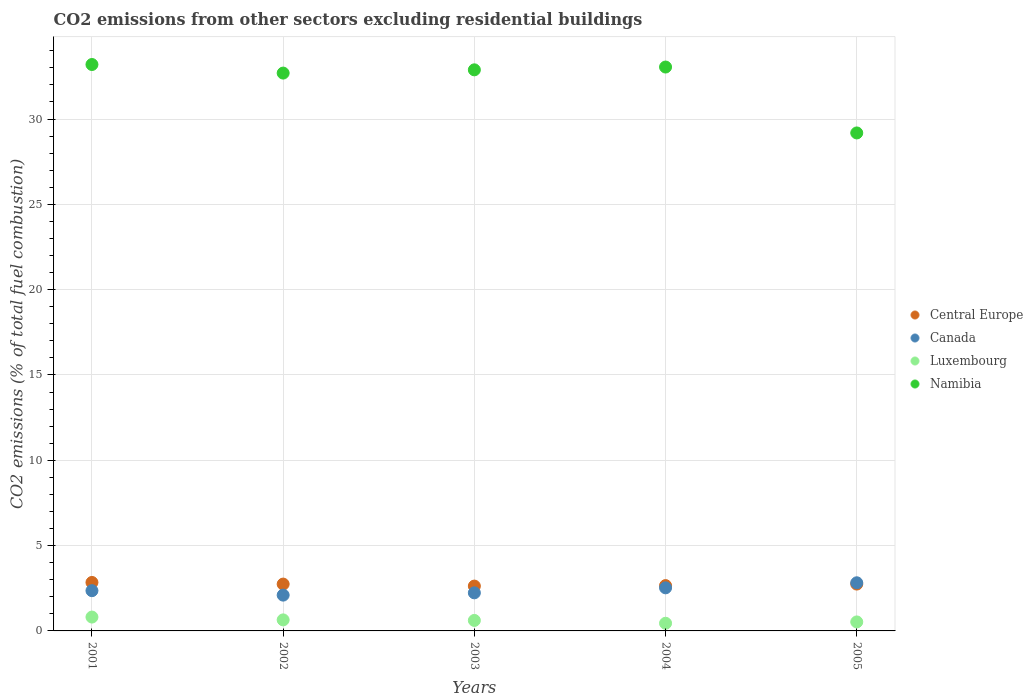What is the total CO2 emitted in Namibia in 2004?
Your response must be concise. 33.05. Across all years, what is the maximum total CO2 emitted in Central Europe?
Make the answer very short. 2.84. Across all years, what is the minimum total CO2 emitted in Luxembourg?
Provide a succinct answer. 0.45. What is the total total CO2 emitted in Namibia in the graph?
Your answer should be very brief. 161. What is the difference between the total CO2 emitted in Canada in 2003 and that in 2004?
Offer a terse response. -0.29. What is the difference between the total CO2 emitted in Luxembourg in 2003 and the total CO2 emitted in Canada in 2005?
Offer a very short reply. -2.21. What is the average total CO2 emitted in Luxembourg per year?
Your answer should be very brief. 0.61. In the year 2002, what is the difference between the total CO2 emitted in Namibia and total CO2 emitted in Luxembourg?
Keep it short and to the point. 32.05. In how many years, is the total CO2 emitted in Namibia greater than 9?
Your answer should be very brief. 5. What is the ratio of the total CO2 emitted in Namibia in 2002 to that in 2005?
Your response must be concise. 1.12. Is the total CO2 emitted in Namibia in 2002 less than that in 2003?
Provide a short and direct response. Yes. What is the difference between the highest and the second highest total CO2 emitted in Canada?
Your answer should be very brief. 0.3. What is the difference between the highest and the lowest total CO2 emitted in Central Europe?
Provide a succinct answer. 0.21. Is the sum of the total CO2 emitted in Canada in 2003 and 2004 greater than the maximum total CO2 emitted in Luxembourg across all years?
Keep it short and to the point. Yes. Is the total CO2 emitted in Canada strictly greater than the total CO2 emitted in Central Europe over the years?
Keep it short and to the point. No. How many dotlines are there?
Your response must be concise. 4. How many years are there in the graph?
Keep it short and to the point. 5. What is the difference between two consecutive major ticks on the Y-axis?
Provide a short and direct response. 5. Are the values on the major ticks of Y-axis written in scientific E-notation?
Keep it short and to the point. No. Does the graph contain grids?
Your answer should be compact. Yes. How many legend labels are there?
Give a very brief answer. 4. How are the legend labels stacked?
Make the answer very short. Vertical. What is the title of the graph?
Provide a succinct answer. CO2 emissions from other sectors excluding residential buildings. Does "Bolivia" appear as one of the legend labels in the graph?
Offer a very short reply. No. What is the label or title of the Y-axis?
Give a very brief answer. CO2 emissions (% of total fuel combustion). What is the CO2 emissions (% of total fuel combustion) in Central Europe in 2001?
Ensure brevity in your answer.  2.84. What is the CO2 emissions (% of total fuel combustion) in Canada in 2001?
Provide a short and direct response. 2.36. What is the CO2 emissions (% of total fuel combustion) of Luxembourg in 2001?
Make the answer very short. 0.81. What is the CO2 emissions (% of total fuel combustion) in Namibia in 2001?
Provide a succinct answer. 33.2. What is the CO2 emissions (% of total fuel combustion) of Central Europe in 2002?
Offer a terse response. 2.74. What is the CO2 emissions (% of total fuel combustion) of Canada in 2002?
Your answer should be very brief. 2.1. What is the CO2 emissions (% of total fuel combustion) in Luxembourg in 2002?
Ensure brevity in your answer.  0.65. What is the CO2 emissions (% of total fuel combustion) of Namibia in 2002?
Give a very brief answer. 32.69. What is the CO2 emissions (% of total fuel combustion) of Central Europe in 2003?
Your response must be concise. 2.63. What is the CO2 emissions (% of total fuel combustion) in Canada in 2003?
Your answer should be compact. 2.23. What is the CO2 emissions (% of total fuel combustion) of Luxembourg in 2003?
Your response must be concise. 0.61. What is the CO2 emissions (% of total fuel combustion) in Namibia in 2003?
Offer a very short reply. 32.88. What is the CO2 emissions (% of total fuel combustion) in Central Europe in 2004?
Ensure brevity in your answer.  2.66. What is the CO2 emissions (% of total fuel combustion) of Canada in 2004?
Make the answer very short. 2.53. What is the CO2 emissions (% of total fuel combustion) in Luxembourg in 2004?
Offer a very short reply. 0.45. What is the CO2 emissions (% of total fuel combustion) of Namibia in 2004?
Your answer should be very brief. 33.05. What is the CO2 emissions (% of total fuel combustion) in Central Europe in 2005?
Your answer should be very brief. 2.75. What is the CO2 emissions (% of total fuel combustion) of Canada in 2005?
Provide a short and direct response. 2.82. What is the CO2 emissions (% of total fuel combustion) of Luxembourg in 2005?
Ensure brevity in your answer.  0.53. What is the CO2 emissions (% of total fuel combustion) in Namibia in 2005?
Your response must be concise. 29.18. Across all years, what is the maximum CO2 emissions (% of total fuel combustion) in Central Europe?
Give a very brief answer. 2.84. Across all years, what is the maximum CO2 emissions (% of total fuel combustion) in Canada?
Offer a very short reply. 2.82. Across all years, what is the maximum CO2 emissions (% of total fuel combustion) of Luxembourg?
Your answer should be very brief. 0.81. Across all years, what is the maximum CO2 emissions (% of total fuel combustion) of Namibia?
Give a very brief answer. 33.2. Across all years, what is the minimum CO2 emissions (% of total fuel combustion) of Central Europe?
Your answer should be very brief. 2.63. Across all years, what is the minimum CO2 emissions (% of total fuel combustion) of Canada?
Provide a short and direct response. 2.1. Across all years, what is the minimum CO2 emissions (% of total fuel combustion) of Luxembourg?
Make the answer very short. 0.45. Across all years, what is the minimum CO2 emissions (% of total fuel combustion) of Namibia?
Provide a succinct answer. 29.18. What is the total CO2 emissions (% of total fuel combustion) in Central Europe in the graph?
Your response must be concise. 13.62. What is the total CO2 emissions (% of total fuel combustion) of Canada in the graph?
Your answer should be very brief. 12.03. What is the total CO2 emissions (% of total fuel combustion) of Luxembourg in the graph?
Give a very brief answer. 3.05. What is the total CO2 emissions (% of total fuel combustion) in Namibia in the graph?
Keep it short and to the point. 161. What is the difference between the CO2 emissions (% of total fuel combustion) of Central Europe in 2001 and that in 2002?
Offer a terse response. 0.1. What is the difference between the CO2 emissions (% of total fuel combustion) in Canada in 2001 and that in 2002?
Give a very brief answer. 0.26. What is the difference between the CO2 emissions (% of total fuel combustion) in Luxembourg in 2001 and that in 2002?
Your response must be concise. 0.17. What is the difference between the CO2 emissions (% of total fuel combustion) in Namibia in 2001 and that in 2002?
Provide a succinct answer. 0.5. What is the difference between the CO2 emissions (% of total fuel combustion) in Central Europe in 2001 and that in 2003?
Make the answer very short. 0.21. What is the difference between the CO2 emissions (% of total fuel combustion) of Canada in 2001 and that in 2003?
Ensure brevity in your answer.  0.13. What is the difference between the CO2 emissions (% of total fuel combustion) of Luxembourg in 2001 and that in 2003?
Ensure brevity in your answer.  0.2. What is the difference between the CO2 emissions (% of total fuel combustion) in Namibia in 2001 and that in 2003?
Offer a very short reply. 0.31. What is the difference between the CO2 emissions (% of total fuel combustion) of Central Europe in 2001 and that in 2004?
Give a very brief answer. 0.18. What is the difference between the CO2 emissions (% of total fuel combustion) of Canada in 2001 and that in 2004?
Your response must be concise. -0.17. What is the difference between the CO2 emissions (% of total fuel combustion) in Luxembourg in 2001 and that in 2004?
Your response must be concise. 0.36. What is the difference between the CO2 emissions (% of total fuel combustion) in Namibia in 2001 and that in 2004?
Make the answer very short. 0.15. What is the difference between the CO2 emissions (% of total fuel combustion) in Central Europe in 2001 and that in 2005?
Ensure brevity in your answer.  0.09. What is the difference between the CO2 emissions (% of total fuel combustion) in Canada in 2001 and that in 2005?
Ensure brevity in your answer.  -0.46. What is the difference between the CO2 emissions (% of total fuel combustion) of Luxembourg in 2001 and that in 2005?
Provide a short and direct response. 0.28. What is the difference between the CO2 emissions (% of total fuel combustion) in Namibia in 2001 and that in 2005?
Your response must be concise. 4.01. What is the difference between the CO2 emissions (% of total fuel combustion) of Central Europe in 2002 and that in 2003?
Give a very brief answer. 0.12. What is the difference between the CO2 emissions (% of total fuel combustion) in Canada in 2002 and that in 2003?
Give a very brief answer. -0.13. What is the difference between the CO2 emissions (% of total fuel combustion) of Luxembourg in 2002 and that in 2003?
Ensure brevity in your answer.  0.03. What is the difference between the CO2 emissions (% of total fuel combustion) of Namibia in 2002 and that in 2003?
Make the answer very short. -0.19. What is the difference between the CO2 emissions (% of total fuel combustion) of Central Europe in 2002 and that in 2004?
Your response must be concise. 0.09. What is the difference between the CO2 emissions (% of total fuel combustion) of Canada in 2002 and that in 2004?
Your answer should be compact. -0.43. What is the difference between the CO2 emissions (% of total fuel combustion) of Luxembourg in 2002 and that in 2004?
Make the answer very short. 0.2. What is the difference between the CO2 emissions (% of total fuel combustion) in Namibia in 2002 and that in 2004?
Provide a short and direct response. -0.35. What is the difference between the CO2 emissions (% of total fuel combustion) of Central Europe in 2002 and that in 2005?
Give a very brief answer. -0. What is the difference between the CO2 emissions (% of total fuel combustion) in Canada in 2002 and that in 2005?
Keep it short and to the point. -0.72. What is the difference between the CO2 emissions (% of total fuel combustion) of Luxembourg in 2002 and that in 2005?
Your answer should be compact. 0.12. What is the difference between the CO2 emissions (% of total fuel combustion) in Namibia in 2002 and that in 2005?
Offer a very short reply. 3.51. What is the difference between the CO2 emissions (% of total fuel combustion) in Central Europe in 2003 and that in 2004?
Ensure brevity in your answer.  -0.03. What is the difference between the CO2 emissions (% of total fuel combustion) of Canada in 2003 and that in 2004?
Give a very brief answer. -0.29. What is the difference between the CO2 emissions (% of total fuel combustion) in Luxembourg in 2003 and that in 2004?
Your response must be concise. 0.17. What is the difference between the CO2 emissions (% of total fuel combustion) of Namibia in 2003 and that in 2004?
Your answer should be very brief. -0.16. What is the difference between the CO2 emissions (% of total fuel combustion) in Central Europe in 2003 and that in 2005?
Your answer should be very brief. -0.12. What is the difference between the CO2 emissions (% of total fuel combustion) in Canada in 2003 and that in 2005?
Offer a terse response. -0.59. What is the difference between the CO2 emissions (% of total fuel combustion) in Luxembourg in 2003 and that in 2005?
Offer a terse response. 0.09. What is the difference between the CO2 emissions (% of total fuel combustion) in Namibia in 2003 and that in 2005?
Your response must be concise. 3.7. What is the difference between the CO2 emissions (% of total fuel combustion) in Central Europe in 2004 and that in 2005?
Your answer should be compact. -0.09. What is the difference between the CO2 emissions (% of total fuel combustion) of Canada in 2004 and that in 2005?
Provide a succinct answer. -0.3. What is the difference between the CO2 emissions (% of total fuel combustion) of Luxembourg in 2004 and that in 2005?
Make the answer very short. -0.08. What is the difference between the CO2 emissions (% of total fuel combustion) of Namibia in 2004 and that in 2005?
Your response must be concise. 3.86. What is the difference between the CO2 emissions (% of total fuel combustion) in Central Europe in 2001 and the CO2 emissions (% of total fuel combustion) in Canada in 2002?
Your answer should be compact. 0.74. What is the difference between the CO2 emissions (% of total fuel combustion) in Central Europe in 2001 and the CO2 emissions (% of total fuel combustion) in Luxembourg in 2002?
Your answer should be very brief. 2.19. What is the difference between the CO2 emissions (% of total fuel combustion) of Central Europe in 2001 and the CO2 emissions (% of total fuel combustion) of Namibia in 2002?
Give a very brief answer. -29.85. What is the difference between the CO2 emissions (% of total fuel combustion) in Canada in 2001 and the CO2 emissions (% of total fuel combustion) in Luxembourg in 2002?
Offer a terse response. 1.71. What is the difference between the CO2 emissions (% of total fuel combustion) of Canada in 2001 and the CO2 emissions (% of total fuel combustion) of Namibia in 2002?
Your response must be concise. -30.33. What is the difference between the CO2 emissions (% of total fuel combustion) in Luxembourg in 2001 and the CO2 emissions (% of total fuel combustion) in Namibia in 2002?
Make the answer very short. -31.88. What is the difference between the CO2 emissions (% of total fuel combustion) in Central Europe in 2001 and the CO2 emissions (% of total fuel combustion) in Canada in 2003?
Give a very brief answer. 0.61. What is the difference between the CO2 emissions (% of total fuel combustion) of Central Europe in 2001 and the CO2 emissions (% of total fuel combustion) of Luxembourg in 2003?
Your answer should be very brief. 2.23. What is the difference between the CO2 emissions (% of total fuel combustion) in Central Europe in 2001 and the CO2 emissions (% of total fuel combustion) in Namibia in 2003?
Your answer should be compact. -30.04. What is the difference between the CO2 emissions (% of total fuel combustion) in Canada in 2001 and the CO2 emissions (% of total fuel combustion) in Luxembourg in 2003?
Keep it short and to the point. 1.74. What is the difference between the CO2 emissions (% of total fuel combustion) in Canada in 2001 and the CO2 emissions (% of total fuel combustion) in Namibia in 2003?
Offer a terse response. -30.52. What is the difference between the CO2 emissions (% of total fuel combustion) in Luxembourg in 2001 and the CO2 emissions (% of total fuel combustion) in Namibia in 2003?
Provide a succinct answer. -32.07. What is the difference between the CO2 emissions (% of total fuel combustion) of Central Europe in 2001 and the CO2 emissions (% of total fuel combustion) of Canada in 2004?
Offer a terse response. 0.32. What is the difference between the CO2 emissions (% of total fuel combustion) of Central Europe in 2001 and the CO2 emissions (% of total fuel combustion) of Luxembourg in 2004?
Provide a succinct answer. 2.39. What is the difference between the CO2 emissions (% of total fuel combustion) in Central Europe in 2001 and the CO2 emissions (% of total fuel combustion) in Namibia in 2004?
Your answer should be compact. -30.21. What is the difference between the CO2 emissions (% of total fuel combustion) of Canada in 2001 and the CO2 emissions (% of total fuel combustion) of Luxembourg in 2004?
Provide a short and direct response. 1.91. What is the difference between the CO2 emissions (% of total fuel combustion) of Canada in 2001 and the CO2 emissions (% of total fuel combustion) of Namibia in 2004?
Offer a terse response. -30.69. What is the difference between the CO2 emissions (% of total fuel combustion) of Luxembourg in 2001 and the CO2 emissions (% of total fuel combustion) of Namibia in 2004?
Offer a terse response. -32.24. What is the difference between the CO2 emissions (% of total fuel combustion) in Central Europe in 2001 and the CO2 emissions (% of total fuel combustion) in Canada in 2005?
Ensure brevity in your answer.  0.02. What is the difference between the CO2 emissions (% of total fuel combustion) in Central Europe in 2001 and the CO2 emissions (% of total fuel combustion) in Luxembourg in 2005?
Provide a succinct answer. 2.31. What is the difference between the CO2 emissions (% of total fuel combustion) of Central Europe in 2001 and the CO2 emissions (% of total fuel combustion) of Namibia in 2005?
Provide a succinct answer. -26.34. What is the difference between the CO2 emissions (% of total fuel combustion) in Canada in 2001 and the CO2 emissions (% of total fuel combustion) in Luxembourg in 2005?
Make the answer very short. 1.83. What is the difference between the CO2 emissions (% of total fuel combustion) of Canada in 2001 and the CO2 emissions (% of total fuel combustion) of Namibia in 2005?
Offer a terse response. -26.83. What is the difference between the CO2 emissions (% of total fuel combustion) of Luxembourg in 2001 and the CO2 emissions (% of total fuel combustion) of Namibia in 2005?
Ensure brevity in your answer.  -28.37. What is the difference between the CO2 emissions (% of total fuel combustion) of Central Europe in 2002 and the CO2 emissions (% of total fuel combustion) of Canada in 2003?
Make the answer very short. 0.51. What is the difference between the CO2 emissions (% of total fuel combustion) of Central Europe in 2002 and the CO2 emissions (% of total fuel combustion) of Luxembourg in 2003?
Your answer should be very brief. 2.13. What is the difference between the CO2 emissions (% of total fuel combustion) in Central Europe in 2002 and the CO2 emissions (% of total fuel combustion) in Namibia in 2003?
Your answer should be compact. -30.14. What is the difference between the CO2 emissions (% of total fuel combustion) of Canada in 2002 and the CO2 emissions (% of total fuel combustion) of Luxembourg in 2003?
Provide a short and direct response. 1.48. What is the difference between the CO2 emissions (% of total fuel combustion) in Canada in 2002 and the CO2 emissions (% of total fuel combustion) in Namibia in 2003?
Ensure brevity in your answer.  -30.78. What is the difference between the CO2 emissions (% of total fuel combustion) of Luxembourg in 2002 and the CO2 emissions (% of total fuel combustion) of Namibia in 2003?
Your response must be concise. -32.24. What is the difference between the CO2 emissions (% of total fuel combustion) of Central Europe in 2002 and the CO2 emissions (% of total fuel combustion) of Canada in 2004?
Ensure brevity in your answer.  0.22. What is the difference between the CO2 emissions (% of total fuel combustion) of Central Europe in 2002 and the CO2 emissions (% of total fuel combustion) of Luxembourg in 2004?
Provide a succinct answer. 2.3. What is the difference between the CO2 emissions (% of total fuel combustion) of Central Europe in 2002 and the CO2 emissions (% of total fuel combustion) of Namibia in 2004?
Your response must be concise. -30.3. What is the difference between the CO2 emissions (% of total fuel combustion) of Canada in 2002 and the CO2 emissions (% of total fuel combustion) of Luxembourg in 2004?
Your answer should be very brief. 1.65. What is the difference between the CO2 emissions (% of total fuel combustion) of Canada in 2002 and the CO2 emissions (% of total fuel combustion) of Namibia in 2004?
Give a very brief answer. -30.95. What is the difference between the CO2 emissions (% of total fuel combustion) of Luxembourg in 2002 and the CO2 emissions (% of total fuel combustion) of Namibia in 2004?
Keep it short and to the point. -32.4. What is the difference between the CO2 emissions (% of total fuel combustion) of Central Europe in 2002 and the CO2 emissions (% of total fuel combustion) of Canada in 2005?
Keep it short and to the point. -0.08. What is the difference between the CO2 emissions (% of total fuel combustion) of Central Europe in 2002 and the CO2 emissions (% of total fuel combustion) of Luxembourg in 2005?
Provide a short and direct response. 2.22. What is the difference between the CO2 emissions (% of total fuel combustion) of Central Europe in 2002 and the CO2 emissions (% of total fuel combustion) of Namibia in 2005?
Offer a terse response. -26.44. What is the difference between the CO2 emissions (% of total fuel combustion) in Canada in 2002 and the CO2 emissions (% of total fuel combustion) in Luxembourg in 2005?
Make the answer very short. 1.57. What is the difference between the CO2 emissions (% of total fuel combustion) in Canada in 2002 and the CO2 emissions (% of total fuel combustion) in Namibia in 2005?
Make the answer very short. -27.09. What is the difference between the CO2 emissions (% of total fuel combustion) of Luxembourg in 2002 and the CO2 emissions (% of total fuel combustion) of Namibia in 2005?
Ensure brevity in your answer.  -28.54. What is the difference between the CO2 emissions (% of total fuel combustion) of Central Europe in 2003 and the CO2 emissions (% of total fuel combustion) of Canada in 2004?
Your answer should be very brief. 0.1. What is the difference between the CO2 emissions (% of total fuel combustion) in Central Europe in 2003 and the CO2 emissions (% of total fuel combustion) in Luxembourg in 2004?
Ensure brevity in your answer.  2.18. What is the difference between the CO2 emissions (% of total fuel combustion) of Central Europe in 2003 and the CO2 emissions (% of total fuel combustion) of Namibia in 2004?
Give a very brief answer. -30.42. What is the difference between the CO2 emissions (% of total fuel combustion) of Canada in 2003 and the CO2 emissions (% of total fuel combustion) of Luxembourg in 2004?
Your answer should be very brief. 1.78. What is the difference between the CO2 emissions (% of total fuel combustion) in Canada in 2003 and the CO2 emissions (% of total fuel combustion) in Namibia in 2004?
Your answer should be very brief. -30.82. What is the difference between the CO2 emissions (% of total fuel combustion) of Luxembourg in 2003 and the CO2 emissions (% of total fuel combustion) of Namibia in 2004?
Keep it short and to the point. -32.43. What is the difference between the CO2 emissions (% of total fuel combustion) of Central Europe in 2003 and the CO2 emissions (% of total fuel combustion) of Canada in 2005?
Your answer should be compact. -0.19. What is the difference between the CO2 emissions (% of total fuel combustion) of Central Europe in 2003 and the CO2 emissions (% of total fuel combustion) of Luxembourg in 2005?
Your answer should be very brief. 2.1. What is the difference between the CO2 emissions (% of total fuel combustion) of Central Europe in 2003 and the CO2 emissions (% of total fuel combustion) of Namibia in 2005?
Ensure brevity in your answer.  -26.56. What is the difference between the CO2 emissions (% of total fuel combustion) of Canada in 2003 and the CO2 emissions (% of total fuel combustion) of Luxembourg in 2005?
Give a very brief answer. 1.7. What is the difference between the CO2 emissions (% of total fuel combustion) in Canada in 2003 and the CO2 emissions (% of total fuel combustion) in Namibia in 2005?
Make the answer very short. -26.95. What is the difference between the CO2 emissions (% of total fuel combustion) in Luxembourg in 2003 and the CO2 emissions (% of total fuel combustion) in Namibia in 2005?
Provide a succinct answer. -28.57. What is the difference between the CO2 emissions (% of total fuel combustion) of Central Europe in 2004 and the CO2 emissions (% of total fuel combustion) of Canada in 2005?
Offer a terse response. -0.16. What is the difference between the CO2 emissions (% of total fuel combustion) of Central Europe in 2004 and the CO2 emissions (% of total fuel combustion) of Luxembourg in 2005?
Ensure brevity in your answer.  2.13. What is the difference between the CO2 emissions (% of total fuel combustion) in Central Europe in 2004 and the CO2 emissions (% of total fuel combustion) in Namibia in 2005?
Offer a terse response. -26.53. What is the difference between the CO2 emissions (% of total fuel combustion) in Canada in 2004 and the CO2 emissions (% of total fuel combustion) in Luxembourg in 2005?
Offer a terse response. 2. What is the difference between the CO2 emissions (% of total fuel combustion) in Canada in 2004 and the CO2 emissions (% of total fuel combustion) in Namibia in 2005?
Your answer should be very brief. -26.66. What is the difference between the CO2 emissions (% of total fuel combustion) of Luxembourg in 2004 and the CO2 emissions (% of total fuel combustion) of Namibia in 2005?
Give a very brief answer. -28.74. What is the average CO2 emissions (% of total fuel combustion) of Central Europe per year?
Your response must be concise. 2.72. What is the average CO2 emissions (% of total fuel combustion) in Canada per year?
Give a very brief answer. 2.41. What is the average CO2 emissions (% of total fuel combustion) of Luxembourg per year?
Provide a succinct answer. 0.61. What is the average CO2 emissions (% of total fuel combustion) of Namibia per year?
Keep it short and to the point. 32.2. In the year 2001, what is the difference between the CO2 emissions (% of total fuel combustion) in Central Europe and CO2 emissions (% of total fuel combustion) in Canada?
Provide a short and direct response. 0.48. In the year 2001, what is the difference between the CO2 emissions (% of total fuel combustion) of Central Europe and CO2 emissions (% of total fuel combustion) of Luxembourg?
Provide a succinct answer. 2.03. In the year 2001, what is the difference between the CO2 emissions (% of total fuel combustion) of Central Europe and CO2 emissions (% of total fuel combustion) of Namibia?
Your response must be concise. -30.35. In the year 2001, what is the difference between the CO2 emissions (% of total fuel combustion) of Canada and CO2 emissions (% of total fuel combustion) of Luxembourg?
Keep it short and to the point. 1.55. In the year 2001, what is the difference between the CO2 emissions (% of total fuel combustion) in Canada and CO2 emissions (% of total fuel combustion) in Namibia?
Provide a short and direct response. -30.84. In the year 2001, what is the difference between the CO2 emissions (% of total fuel combustion) of Luxembourg and CO2 emissions (% of total fuel combustion) of Namibia?
Make the answer very short. -32.38. In the year 2002, what is the difference between the CO2 emissions (% of total fuel combustion) in Central Europe and CO2 emissions (% of total fuel combustion) in Canada?
Provide a short and direct response. 0.65. In the year 2002, what is the difference between the CO2 emissions (% of total fuel combustion) in Central Europe and CO2 emissions (% of total fuel combustion) in Luxembourg?
Make the answer very short. 2.1. In the year 2002, what is the difference between the CO2 emissions (% of total fuel combustion) in Central Europe and CO2 emissions (% of total fuel combustion) in Namibia?
Your response must be concise. -29.95. In the year 2002, what is the difference between the CO2 emissions (% of total fuel combustion) of Canada and CO2 emissions (% of total fuel combustion) of Luxembourg?
Your answer should be compact. 1.45. In the year 2002, what is the difference between the CO2 emissions (% of total fuel combustion) of Canada and CO2 emissions (% of total fuel combustion) of Namibia?
Your response must be concise. -30.59. In the year 2002, what is the difference between the CO2 emissions (% of total fuel combustion) of Luxembourg and CO2 emissions (% of total fuel combustion) of Namibia?
Your answer should be very brief. -32.05. In the year 2003, what is the difference between the CO2 emissions (% of total fuel combustion) of Central Europe and CO2 emissions (% of total fuel combustion) of Canada?
Your response must be concise. 0.4. In the year 2003, what is the difference between the CO2 emissions (% of total fuel combustion) of Central Europe and CO2 emissions (% of total fuel combustion) of Luxembourg?
Offer a terse response. 2.01. In the year 2003, what is the difference between the CO2 emissions (% of total fuel combustion) in Central Europe and CO2 emissions (% of total fuel combustion) in Namibia?
Ensure brevity in your answer.  -30.25. In the year 2003, what is the difference between the CO2 emissions (% of total fuel combustion) in Canada and CO2 emissions (% of total fuel combustion) in Luxembourg?
Ensure brevity in your answer.  1.62. In the year 2003, what is the difference between the CO2 emissions (% of total fuel combustion) in Canada and CO2 emissions (% of total fuel combustion) in Namibia?
Make the answer very short. -30.65. In the year 2003, what is the difference between the CO2 emissions (% of total fuel combustion) in Luxembourg and CO2 emissions (% of total fuel combustion) in Namibia?
Ensure brevity in your answer.  -32.27. In the year 2004, what is the difference between the CO2 emissions (% of total fuel combustion) of Central Europe and CO2 emissions (% of total fuel combustion) of Canada?
Ensure brevity in your answer.  0.13. In the year 2004, what is the difference between the CO2 emissions (% of total fuel combustion) in Central Europe and CO2 emissions (% of total fuel combustion) in Luxembourg?
Your answer should be very brief. 2.21. In the year 2004, what is the difference between the CO2 emissions (% of total fuel combustion) of Central Europe and CO2 emissions (% of total fuel combustion) of Namibia?
Offer a very short reply. -30.39. In the year 2004, what is the difference between the CO2 emissions (% of total fuel combustion) in Canada and CO2 emissions (% of total fuel combustion) in Luxembourg?
Your response must be concise. 2.08. In the year 2004, what is the difference between the CO2 emissions (% of total fuel combustion) in Canada and CO2 emissions (% of total fuel combustion) in Namibia?
Provide a short and direct response. -30.52. In the year 2004, what is the difference between the CO2 emissions (% of total fuel combustion) of Luxembourg and CO2 emissions (% of total fuel combustion) of Namibia?
Provide a succinct answer. -32.6. In the year 2005, what is the difference between the CO2 emissions (% of total fuel combustion) in Central Europe and CO2 emissions (% of total fuel combustion) in Canada?
Provide a short and direct response. -0.08. In the year 2005, what is the difference between the CO2 emissions (% of total fuel combustion) in Central Europe and CO2 emissions (% of total fuel combustion) in Luxembourg?
Provide a succinct answer. 2.22. In the year 2005, what is the difference between the CO2 emissions (% of total fuel combustion) in Central Europe and CO2 emissions (% of total fuel combustion) in Namibia?
Your response must be concise. -26.44. In the year 2005, what is the difference between the CO2 emissions (% of total fuel combustion) in Canada and CO2 emissions (% of total fuel combustion) in Luxembourg?
Keep it short and to the point. 2.29. In the year 2005, what is the difference between the CO2 emissions (% of total fuel combustion) in Canada and CO2 emissions (% of total fuel combustion) in Namibia?
Give a very brief answer. -26.36. In the year 2005, what is the difference between the CO2 emissions (% of total fuel combustion) in Luxembourg and CO2 emissions (% of total fuel combustion) in Namibia?
Provide a succinct answer. -28.66. What is the ratio of the CO2 emissions (% of total fuel combustion) in Central Europe in 2001 to that in 2002?
Offer a very short reply. 1.03. What is the ratio of the CO2 emissions (% of total fuel combustion) of Canada in 2001 to that in 2002?
Ensure brevity in your answer.  1.12. What is the ratio of the CO2 emissions (% of total fuel combustion) in Luxembourg in 2001 to that in 2002?
Provide a short and direct response. 1.26. What is the ratio of the CO2 emissions (% of total fuel combustion) in Namibia in 2001 to that in 2002?
Provide a short and direct response. 1.02. What is the ratio of the CO2 emissions (% of total fuel combustion) in Central Europe in 2001 to that in 2003?
Ensure brevity in your answer.  1.08. What is the ratio of the CO2 emissions (% of total fuel combustion) of Canada in 2001 to that in 2003?
Keep it short and to the point. 1.06. What is the ratio of the CO2 emissions (% of total fuel combustion) of Luxembourg in 2001 to that in 2003?
Provide a succinct answer. 1.32. What is the ratio of the CO2 emissions (% of total fuel combustion) in Namibia in 2001 to that in 2003?
Keep it short and to the point. 1.01. What is the ratio of the CO2 emissions (% of total fuel combustion) of Central Europe in 2001 to that in 2004?
Provide a succinct answer. 1.07. What is the ratio of the CO2 emissions (% of total fuel combustion) in Canada in 2001 to that in 2004?
Your answer should be compact. 0.93. What is the ratio of the CO2 emissions (% of total fuel combustion) in Luxembourg in 2001 to that in 2004?
Your response must be concise. 1.81. What is the ratio of the CO2 emissions (% of total fuel combustion) in Namibia in 2001 to that in 2004?
Provide a succinct answer. 1. What is the ratio of the CO2 emissions (% of total fuel combustion) of Central Europe in 2001 to that in 2005?
Ensure brevity in your answer.  1.03. What is the ratio of the CO2 emissions (% of total fuel combustion) of Canada in 2001 to that in 2005?
Provide a short and direct response. 0.84. What is the ratio of the CO2 emissions (% of total fuel combustion) in Luxembourg in 2001 to that in 2005?
Your response must be concise. 1.54. What is the ratio of the CO2 emissions (% of total fuel combustion) of Namibia in 2001 to that in 2005?
Your answer should be compact. 1.14. What is the ratio of the CO2 emissions (% of total fuel combustion) in Central Europe in 2002 to that in 2003?
Provide a short and direct response. 1.04. What is the ratio of the CO2 emissions (% of total fuel combustion) in Canada in 2002 to that in 2003?
Give a very brief answer. 0.94. What is the ratio of the CO2 emissions (% of total fuel combustion) in Luxembourg in 2002 to that in 2003?
Your answer should be compact. 1.05. What is the ratio of the CO2 emissions (% of total fuel combustion) of Namibia in 2002 to that in 2003?
Ensure brevity in your answer.  0.99. What is the ratio of the CO2 emissions (% of total fuel combustion) in Canada in 2002 to that in 2004?
Offer a very short reply. 0.83. What is the ratio of the CO2 emissions (% of total fuel combustion) of Luxembourg in 2002 to that in 2004?
Give a very brief answer. 1.44. What is the ratio of the CO2 emissions (% of total fuel combustion) in Namibia in 2002 to that in 2004?
Make the answer very short. 0.99. What is the ratio of the CO2 emissions (% of total fuel combustion) of Central Europe in 2002 to that in 2005?
Ensure brevity in your answer.  1. What is the ratio of the CO2 emissions (% of total fuel combustion) in Canada in 2002 to that in 2005?
Provide a succinct answer. 0.74. What is the ratio of the CO2 emissions (% of total fuel combustion) in Luxembourg in 2002 to that in 2005?
Your answer should be very brief. 1.23. What is the ratio of the CO2 emissions (% of total fuel combustion) in Namibia in 2002 to that in 2005?
Your response must be concise. 1.12. What is the ratio of the CO2 emissions (% of total fuel combustion) in Central Europe in 2003 to that in 2004?
Keep it short and to the point. 0.99. What is the ratio of the CO2 emissions (% of total fuel combustion) of Canada in 2003 to that in 2004?
Offer a very short reply. 0.88. What is the ratio of the CO2 emissions (% of total fuel combustion) in Luxembourg in 2003 to that in 2004?
Make the answer very short. 1.37. What is the ratio of the CO2 emissions (% of total fuel combustion) in Central Europe in 2003 to that in 2005?
Your answer should be very brief. 0.96. What is the ratio of the CO2 emissions (% of total fuel combustion) of Canada in 2003 to that in 2005?
Keep it short and to the point. 0.79. What is the ratio of the CO2 emissions (% of total fuel combustion) of Luxembourg in 2003 to that in 2005?
Provide a short and direct response. 1.17. What is the ratio of the CO2 emissions (% of total fuel combustion) of Namibia in 2003 to that in 2005?
Make the answer very short. 1.13. What is the ratio of the CO2 emissions (% of total fuel combustion) of Central Europe in 2004 to that in 2005?
Your answer should be compact. 0.97. What is the ratio of the CO2 emissions (% of total fuel combustion) of Canada in 2004 to that in 2005?
Give a very brief answer. 0.9. What is the ratio of the CO2 emissions (% of total fuel combustion) in Luxembourg in 2004 to that in 2005?
Ensure brevity in your answer.  0.85. What is the ratio of the CO2 emissions (% of total fuel combustion) of Namibia in 2004 to that in 2005?
Ensure brevity in your answer.  1.13. What is the difference between the highest and the second highest CO2 emissions (% of total fuel combustion) in Central Europe?
Offer a terse response. 0.09. What is the difference between the highest and the second highest CO2 emissions (% of total fuel combustion) in Canada?
Offer a terse response. 0.3. What is the difference between the highest and the second highest CO2 emissions (% of total fuel combustion) of Luxembourg?
Offer a terse response. 0.17. What is the difference between the highest and the second highest CO2 emissions (% of total fuel combustion) in Namibia?
Your response must be concise. 0.15. What is the difference between the highest and the lowest CO2 emissions (% of total fuel combustion) of Central Europe?
Provide a succinct answer. 0.21. What is the difference between the highest and the lowest CO2 emissions (% of total fuel combustion) in Canada?
Your answer should be very brief. 0.72. What is the difference between the highest and the lowest CO2 emissions (% of total fuel combustion) of Luxembourg?
Your answer should be very brief. 0.36. What is the difference between the highest and the lowest CO2 emissions (% of total fuel combustion) of Namibia?
Keep it short and to the point. 4.01. 